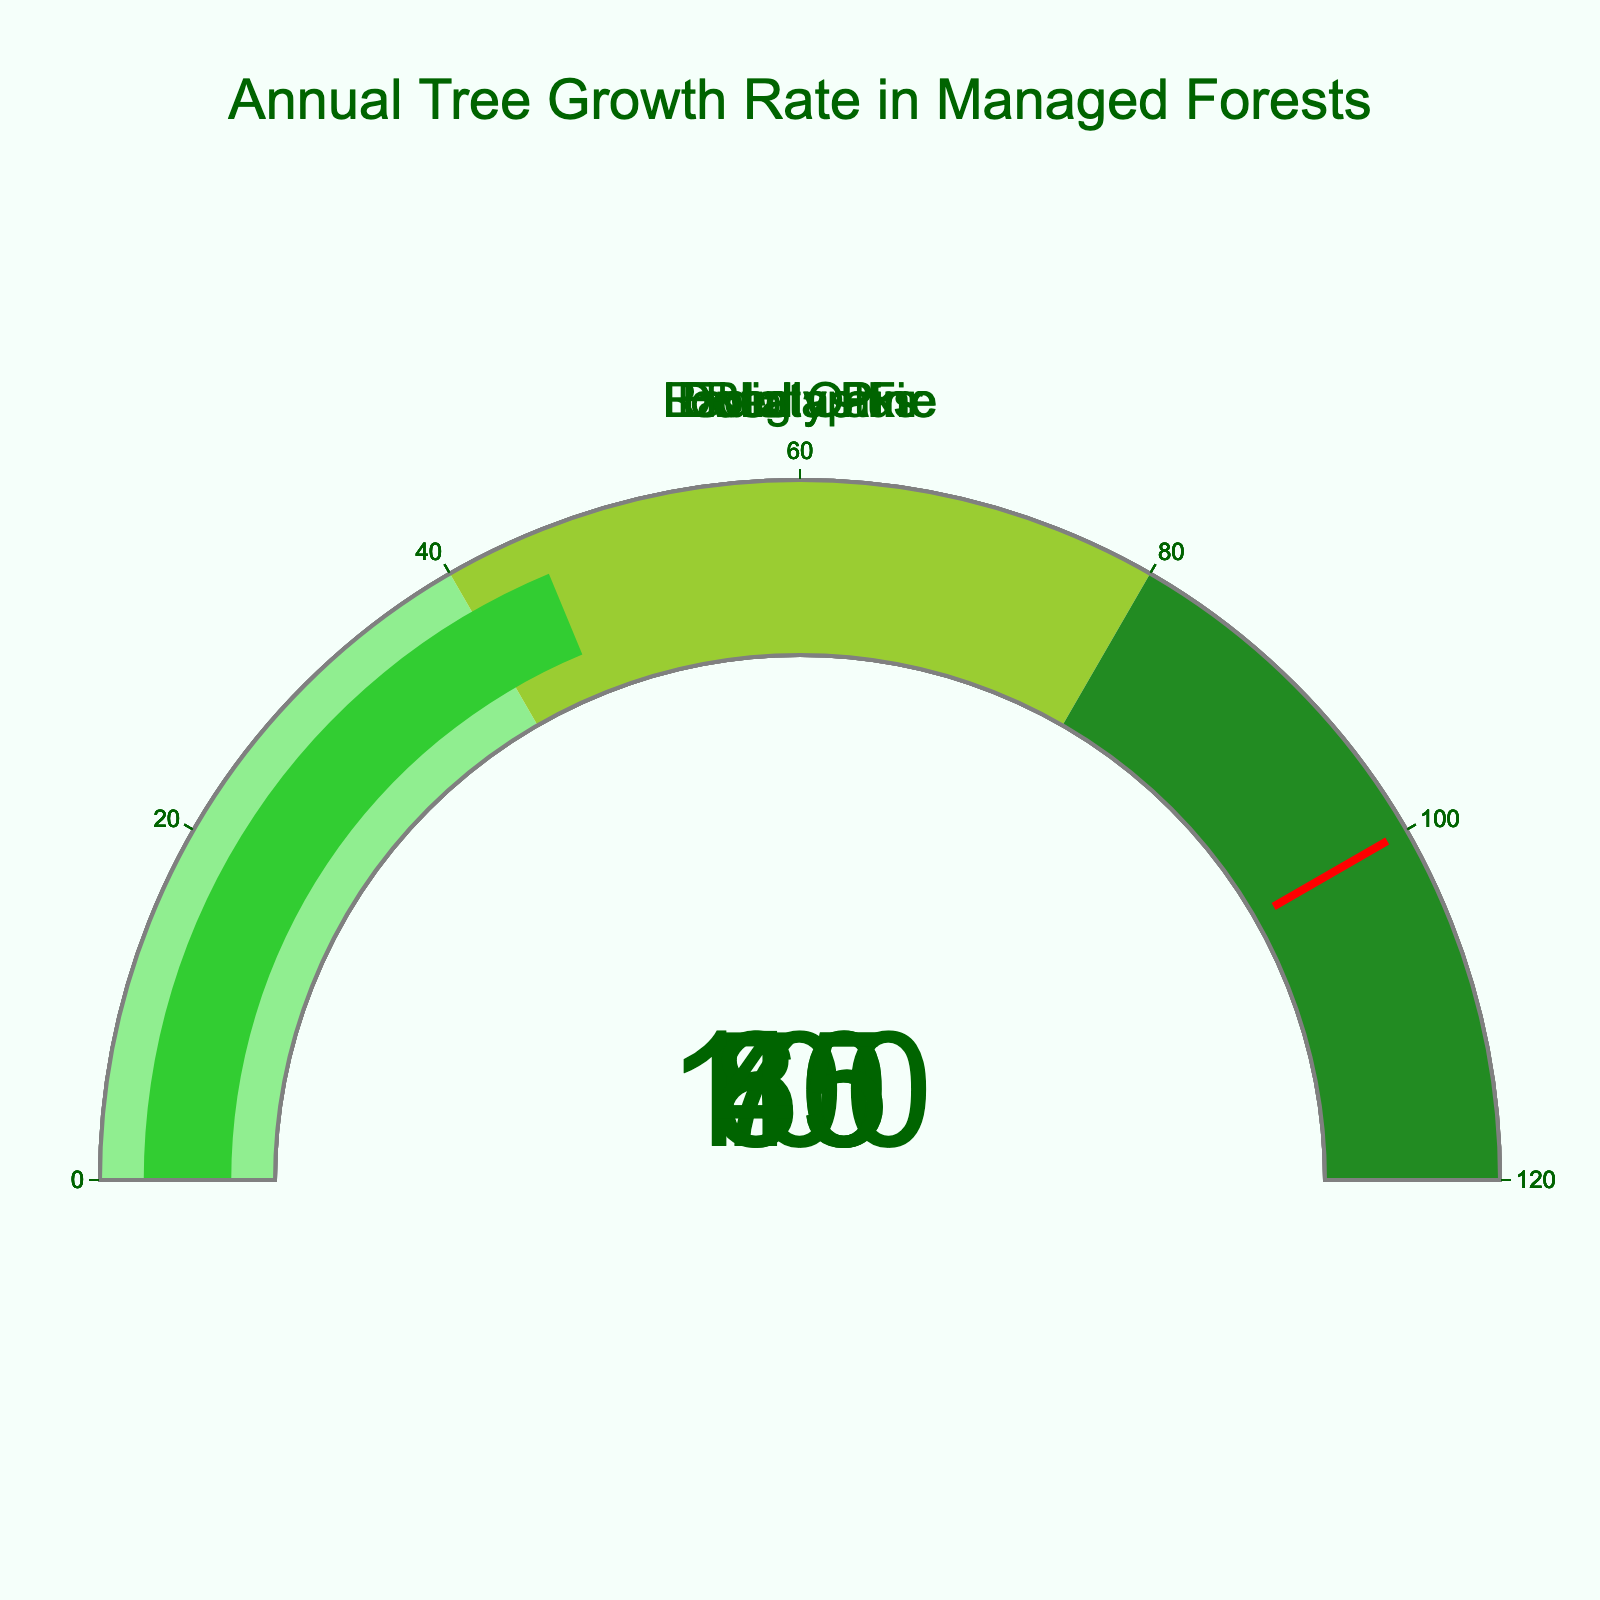How many species are displayed in the figure? The figure represents five different species, which can be counted from the Gauges displaying Growth Rates for Douglas Fir, Loblolly Pine, Eucalyptus, Radiata Pine, and Red Oak.
Answer: Five What is the range of growth rates covered in the figure? The Growth Rates range from 45 cm/year (for Red Oak) to 100 cm/year (for Eucalyptus).
Answer: 45 to 100 cm/year Which species has the highest growth rate? By looking at the Gauges, Eucalyptus has the highest growth rate of 100 cm/year.
Answer: Eucalyptus What is the difference in growth rates between Douglas Fir and Red Oak? Douglas Fir grows at 60 cm/year, and Red Oak grows at 45 cm/year. The difference is 60 - 45 = 15 cm/year.
Answer: 15 cm/year Is there any species with a growth rate in the range of 70-80 cm/year? Yes, Loblolly Pine and Radiata Pine both have growth rates within this range with 75 cm/year and 80 cm/year respectively.
Answer: Yes Among the species displayed, which ones have growth rates above 75 cm/year? Loblolly Pine (75 cm/year), Eucalyptus (100 cm/year), and Radiata Pine (80 cm/year) have growth rates above 75 cm/year.
Answer: Loblolly Pine, Eucalyptus, Radiata Pine What's the average growth rate of all displayed species? Sum the Growth Rates of all species (60 + 75 + 100 + 80 + 45 = 360), then divide by the number of species (360 / 5 = 72). The average growth rate is 72 cm/year.
Answer: 72 cm/year Does any species surpass the threshold value of 100 cm/year? The threshold value set in the gauges for growth is 100 cm/year. Only Eucalyptus meets this value, but does not surpass it.
Answer: No 